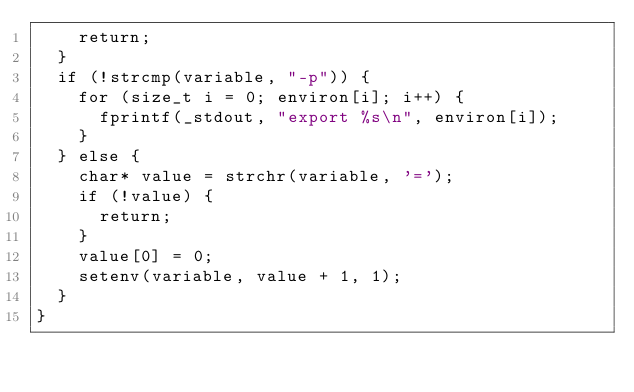Convert code to text. <code><loc_0><loc_0><loc_500><loc_500><_C_>    return;
  }
  if (!strcmp(variable, "-p")) {
    for (size_t i = 0; environ[i]; i++) {
      fprintf(_stdout, "export %s\n", environ[i]);
    }
  } else {
    char* value = strchr(variable, '=');
    if (!value) {
      return;
    }
    value[0] = 0;
    setenv(variable, value + 1, 1);
  }
}
</code> 